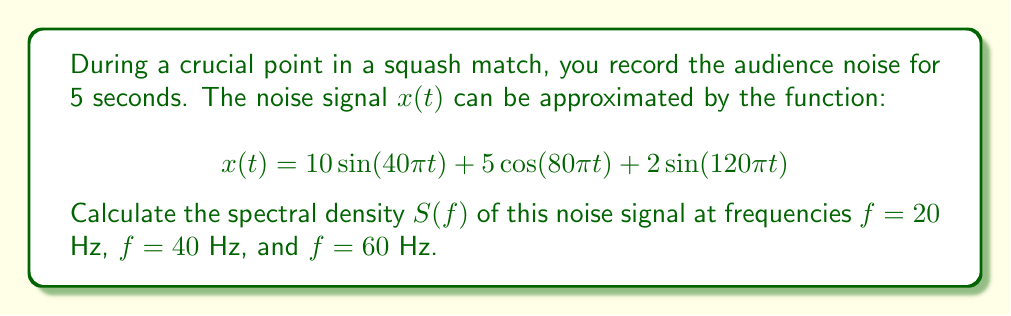Give your solution to this math problem. To solve this problem, we'll follow these steps:

1) The spectral density $S(f)$ is the square of the magnitude of the Fourier transform of the signal. For a continuous-time signal, it's given by:

   $$S(f) = |X(f)|^2$$

   where $X(f)$ is the Fourier transform of $x(t)$.

2) For a sinusoidal signal $A\sin(2\pi f_0 t)$ or $A\cos(2\pi f_0 t)$, the Fourier transform is a pair of delta functions at $\pm f_0$:

   $$\mathcal{F}\{A\sin(2\pi f_0 t)\} = \frac{A}{2j}[\delta(f-f_0) - \delta(f+f_0)]$$
   $$\mathcal{F}\{A\cos(2\pi f_0 t)\} = \frac{A}{2}[\delta(f-f_0) + \delta(f+f_0)]$$

3) Our signal consists of three components:
   - $10\sin(40\pi t)$ with $f_0 = 20$ Hz and $A = 10$
   - $5\cos(80\pi t)$ with $f_0 = 40$ Hz and $A = 5$
   - $2\sin(120\pi t)$ with $f_0 = 60$ Hz and $A = 2$

4) The Fourier transform of our signal is:

   $$X(f) = 5j[\delta(f-20) - \delta(f+20)] + \frac{5}{2}[\delta(f-40) + \delta(f+40)] + j[\delta(f-60) - \delta(f+60)]$$

5) The spectral density is $S(f) = |X(f)|^2$. At the frequencies of interest:

   At $f = 20$ Hz: $S(20) = |5j|^2 = 25$
   At $f = 40$ Hz: $S(40) = |\frac{5}{2}|^2 = \frac{25}{4} = 6.25$
   At $f = 60$ Hz: $S(60) = |j|^2 = 1$

Therefore, the spectral density values at the given frequencies are 25, 6.25, and 1 respectively.
Answer: $S(20) = 25$, $S(40) = 6.25$, $S(60) = 1$ 